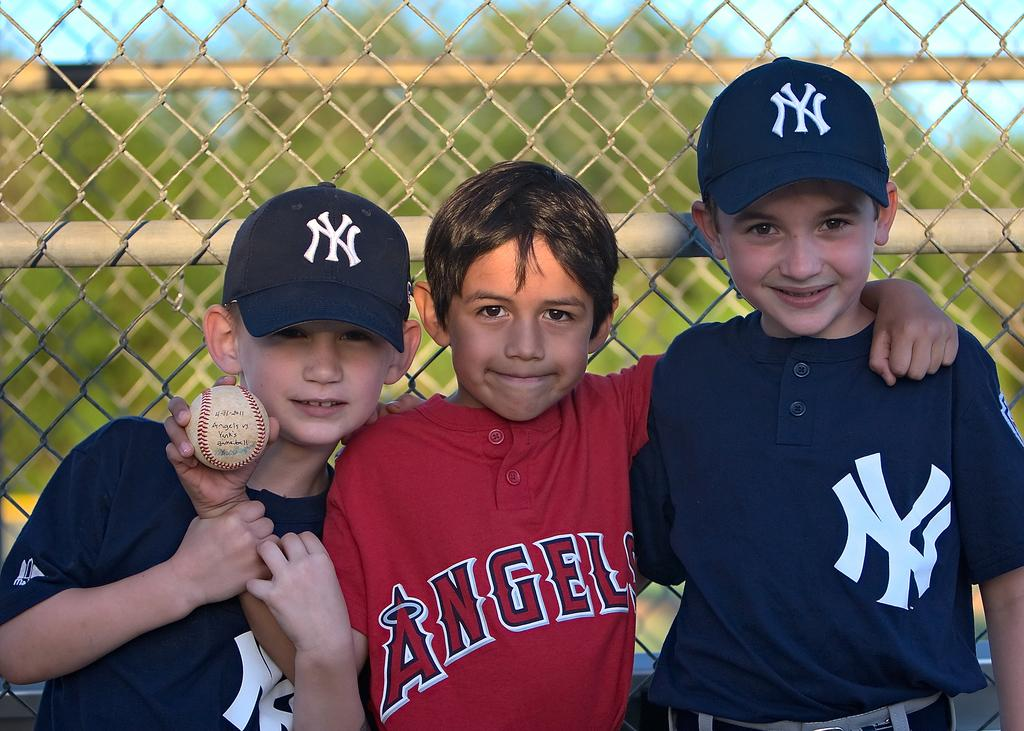<image>
Present a compact description of the photo's key features. Two NY Yankee fans and an Angels fan are standing in front of a fence with their arms around each other. 